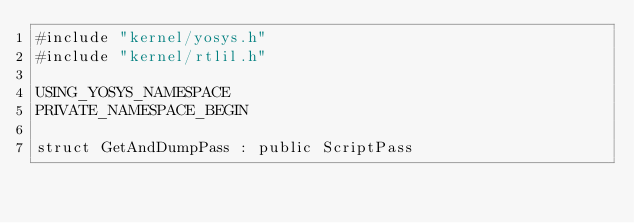Convert code to text. <code><loc_0><loc_0><loc_500><loc_500><_C++_>#include "kernel/yosys.h"
#include "kernel/rtlil.h"

USING_YOSYS_NAMESPACE
PRIVATE_NAMESPACE_BEGIN

struct GetAndDumpPass : public ScriptPass</code> 